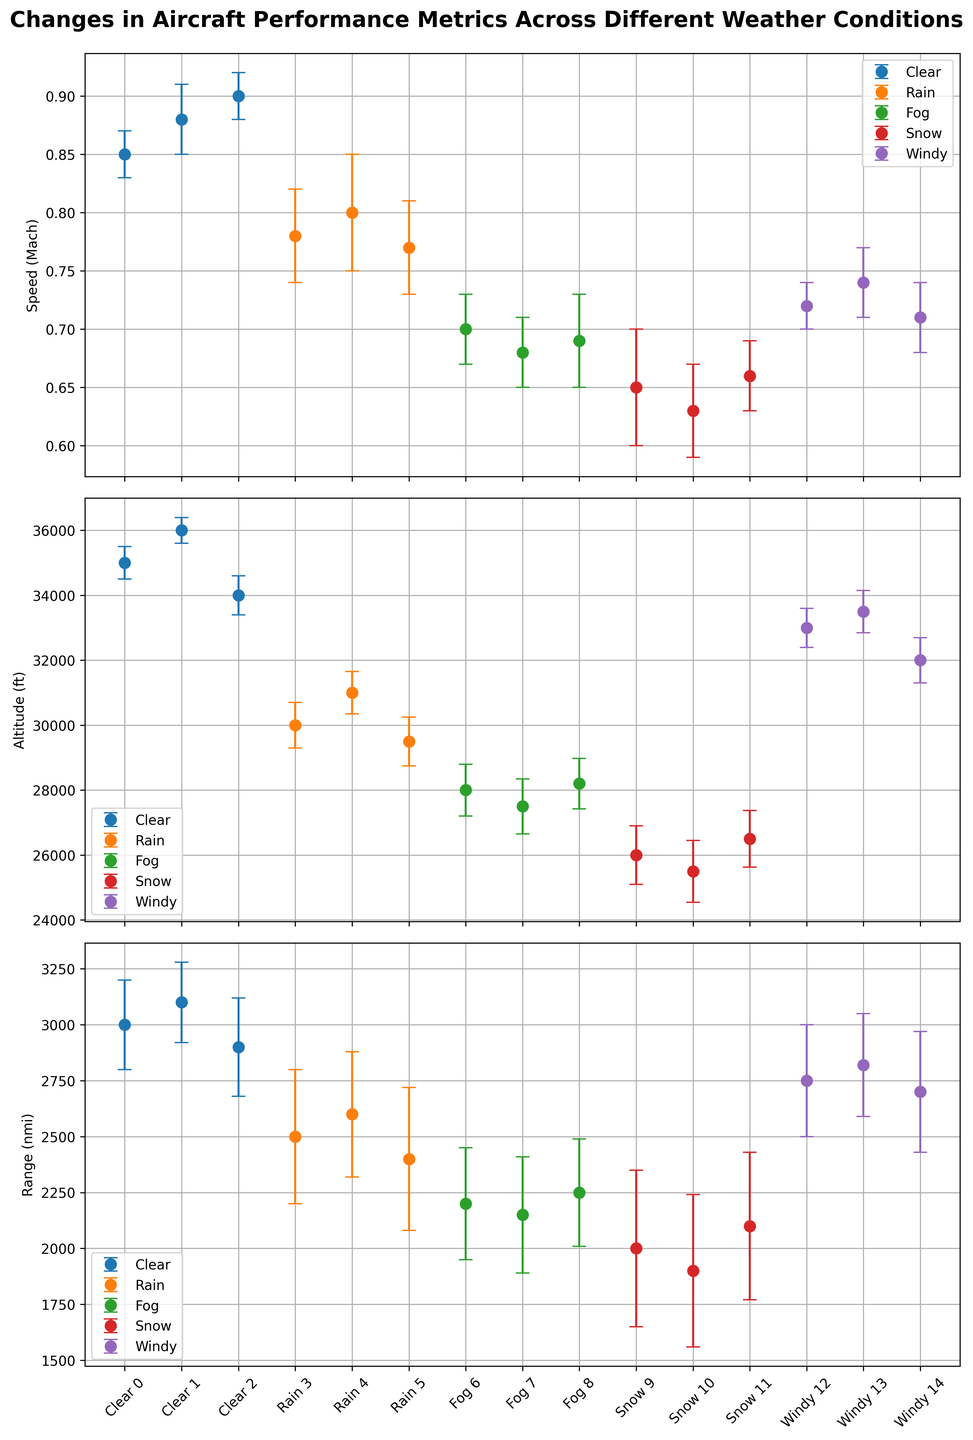What weather condition results in the highest average aircraft speed? To find the highest average aircraft speed, look at the average speed values for each weather condition. Clear weather has speed values of 0.85, 0.88, and 0.90 Mach. Rain has speed values of 0.78, 0.80, and 0.77 Mach. Fog has speed values of 0.70, 0.68, and 0.69 Mach. Snow has speed values of 0.65, 0.63, and 0.66 Mach. Windy has speed values of 0.72, 0.74, and 0.71 Mach. The highest average speed is in Clear weather.
Answer: Clear Which weather condition has the most variation in altitude? To determine the weather condition with the most variation in altitude, observe the error bars for the altitude metric. Rain weather shows considerable altitude variations represented by larger error bars.
Answer: Rain How does the average range change between Clear and Snow conditions? Calculate the average range for Clear (3000+3100+2900) / 3 = 3000 nmi and for Snow (2000+1900+2100) / 3 ≈ 2000 nmi. Compare the averages indicating a decrease.
Answer: Decreases (by around 1000 nmi) What is the lowest recorded speed under any weather condition? Look at all the data points across different weather conditions. The lowest speed value is 0.63 Mach under Snow conditions.
Answer: 0.63 Mach How does the performance in Windy conditions compare to Rainy conditions in terms of range? For Windy, the range values are 2750, 2820, and 2700 nmi, resulting in an average of (2750 + 2820 + 2700) / 3 ≈ 2756.67 nmi. For Rain, the values are 2500, 2600, and 2400 nmi, averaging (2500 + 2600 + 2400) / 3 ≈ 2500 nmi. Windy conditions have a higher average range.
Answer: Windy has a higher average range What visual difference stands out between the error bars for speed and altitude? Observe the length of the error bars. The error bars for altitude are much longer compared to those for speed, indicating more variability in altitude.
Answer: Altitude has longer error bars Which weather condition has the least average error in range? Compare the range error values for each weather condition. The Clear condition has errors (200, 180, 220) averaging (200 + 180 + 220) / 3 ≈ 200 nmi, which is the lowest among all conditions.
Answer: Clear What is the effect of Fog on altitude compared to Clear conditions? For Fog, the altitude values are 28000, 27500, and 28200 ft. Averaging these gives (28000 + 27500 + 28200) / 3 ≈ 27900 ft. For Clear, the values are 35000, 36000, and 34000 ft, averaging (35000 + 36000 + 34000) / 3 ≈ 35000 ft. Fog lowers the altitude compared to Clear conditions.
Answer: Lowers (by around 7100 ft) What is the difference in the highest and lowest average altitudes recorded? The highest average altitude is in Clear weather, which is 35000 ft. The lowest is in Snow conditions, averaging (26000 + 25500 + 26500) / 3 ≈ 26000 ft, yielding a difference of 35000 - 26000 = 9000 ft.
Answer: 9000 ft 